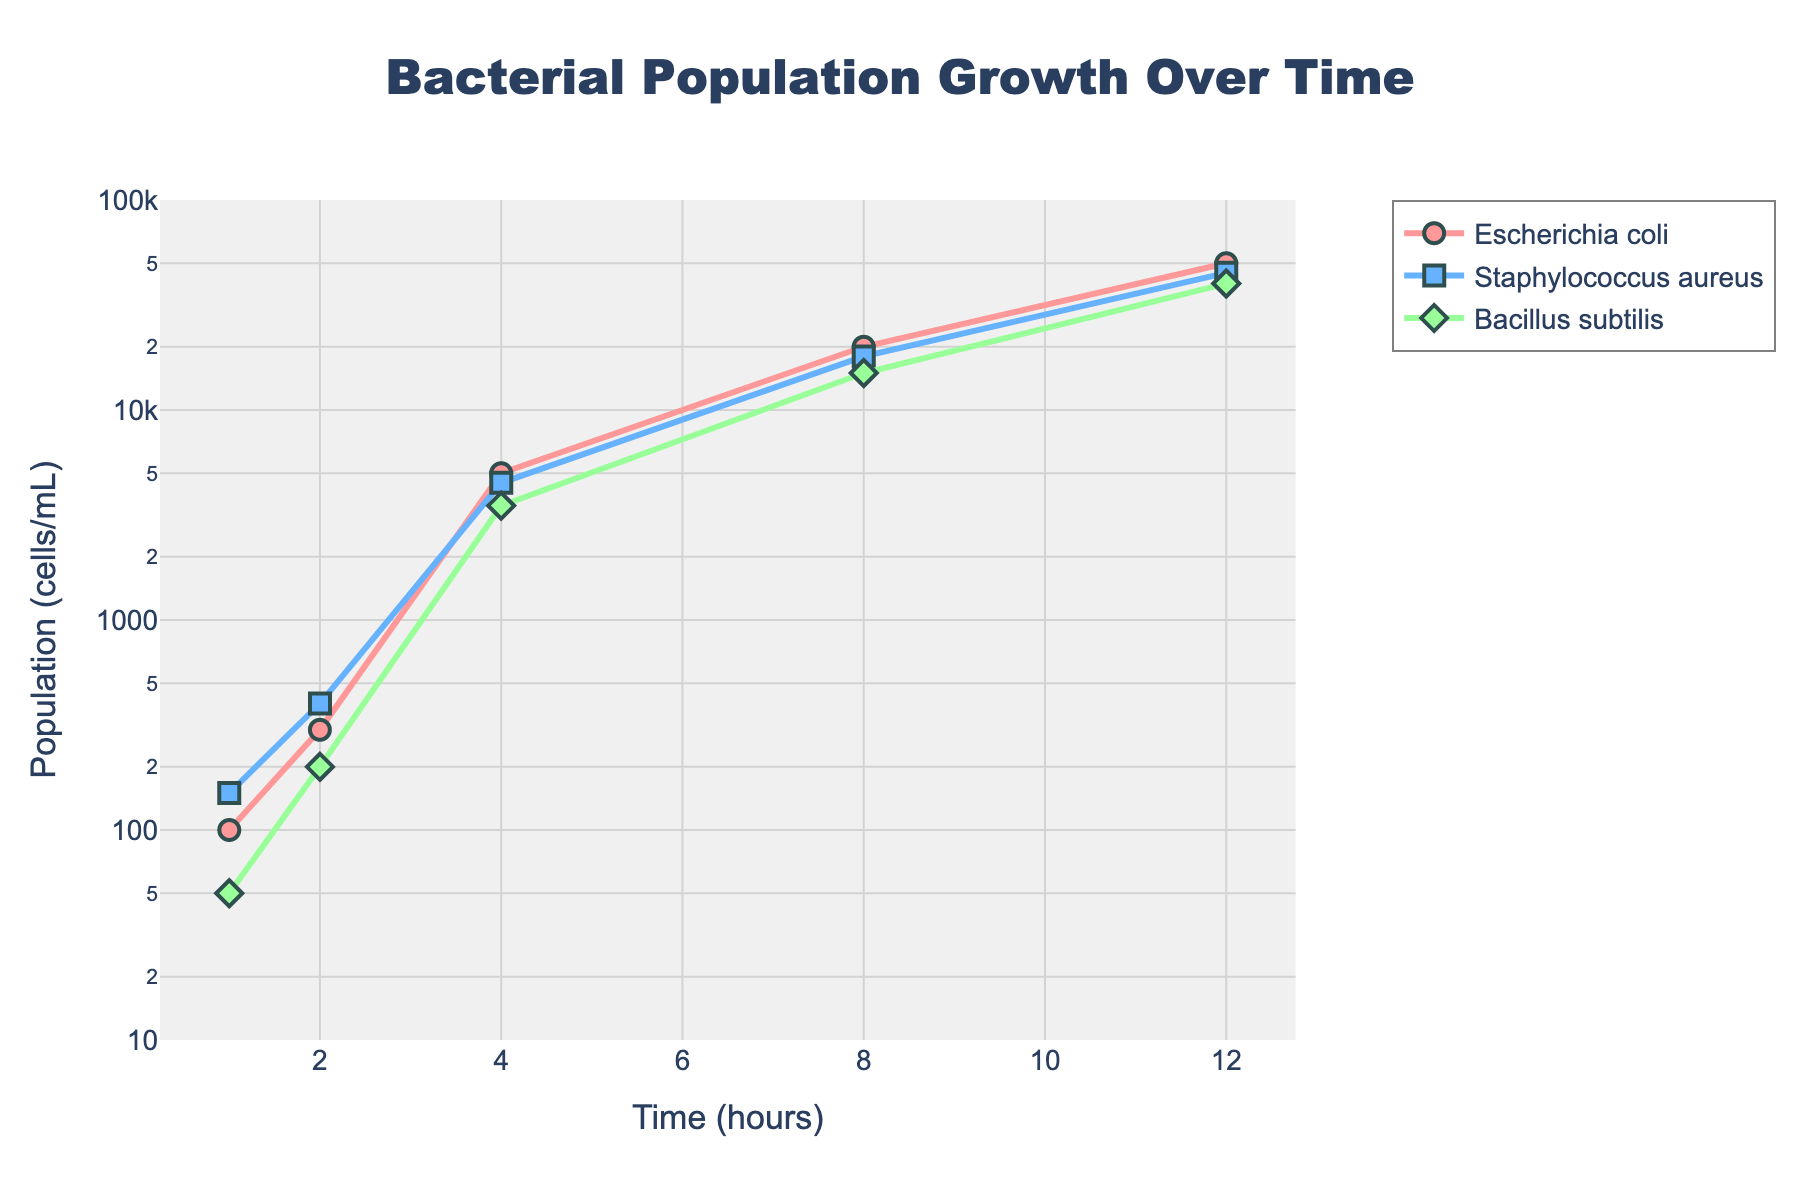What is the title of the figure? The title is prominently displayed at the top center of the figure, clearly stating the subject it represents.
Answer: Bacterial Population Growth Over Time Which bacterial strain has the highest population at the 12-hour mark? By observing the y-axis values at the 12-hour time point for each bacterial strain, we can see which one reaches the highest population.
Answer: Escherichia coli At what time point does Bacillus subtilis first reach a population of 10,000 cells/mL? We examine the plot for Bacillus subtilis and look for the time point where its curve first intersects or surpasses the 10,000 cells/mL mark on the y-axis.
Answer: 8 hours How many distinct bacterial strains are shown in the figure? By counting the different names of the bacterial strains listed in the legend, we can determine the number of unique strains represented.
Answer: 3 Which bacterial strain shows the fastest initial growth rate between 1 and 2 hours? By comparing the slope of the lines between the 1-hour and 2-hour marks for each strain, the strain with the steepest slope has the fastest initial growth rate.
Answer: Escherichia coli What is the overall trend in population growth for Staphylococcus aureus between 4 and 8 hours? By observing the curve representing Staphylococcus aureus between the 4-hour and 8-hour time points, we can describe the trend in population growth.
Answer: Rapid increase Between which two time points does Escherichia coli’s population increase the most in absolute terms? To find the largest absolute increase, we compare the differences in Escherichia coli’s population between consecutive time points, identifying the pair with the greatest difference.
Answer: Between 2 and 4 hours Compare the population of Escherichia coli and Bacillus subtilis at 4 hours. Which one is greater and by how many cells/mL? By looking at the population values for both strains at the 4-hour time point and subtracting the smaller value from the larger one, we find the difference.
Answer: Escherichia coli by 1,500 cells/mL What general pattern can be observed about the growth of all bacterial strains shown in the figure? By observing all the curves, we can describe the common pattern of how the population of each bacterial strain changes over time.
Answer: Exponential growth 